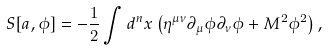<formula> <loc_0><loc_0><loc_500><loc_500>S [ a , \phi ] = - \frac { 1 } { 2 } \int d ^ { n } x \left ( \eta ^ { \mu \nu } \partial _ { \mu } \phi \partial _ { \nu } \phi + M ^ { 2 } \phi ^ { 2 } \right ) ,</formula> 